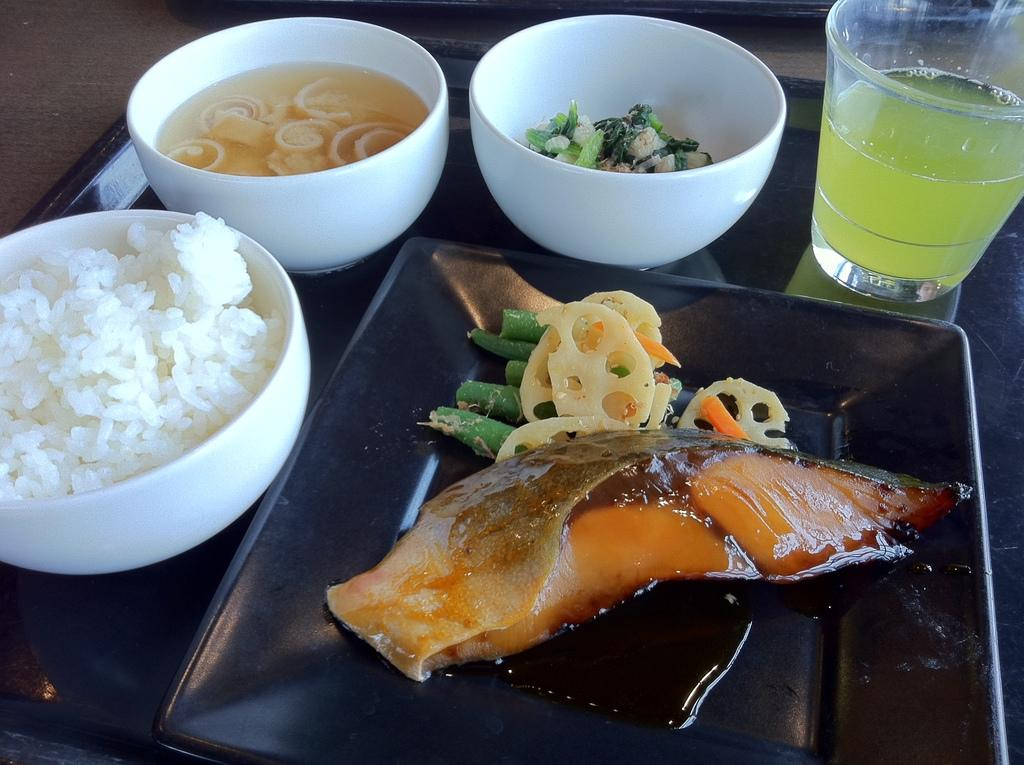What is in the glass that is visible in the image? There is a drink in the glass in the image. What else can be seen on the tray besides the glass? There are bowls with food and a plate with meat on the tray. Where is the tray located in the image? The tray is on a table in the image. What type of laborer is working on the sail in the image? There is no laborer or sail present in the image; it only features a glass with a drink, bowls with food, a plate with meat, a tray, and a table. 